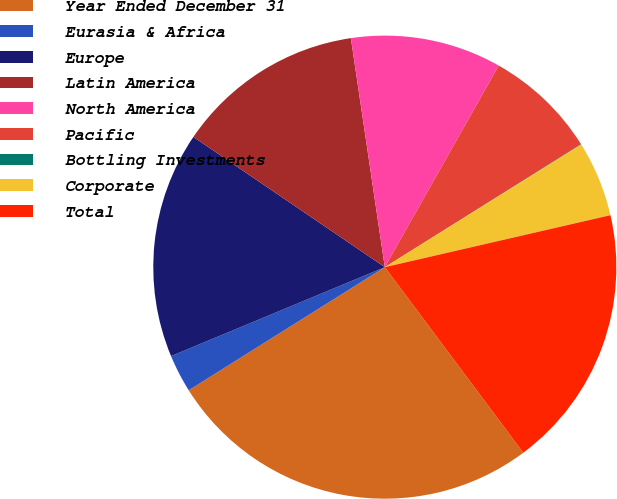Convert chart to OTSL. <chart><loc_0><loc_0><loc_500><loc_500><pie_chart><fcel>Year Ended December 31<fcel>Eurasia & Africa<fcel>Europe<fcel>Latin America<fcel>North America<fcel>Pacific<fcel>Bottling Investments<fcel>Corporate<fcel>Total<nl><fcel>26.28%<fcel>2.65%<fcel>15.78%<fcel>13.15%<fcel>10.53%<fcel>7.9%<fcel>0.03%<fcel>5.28%<fcel>18.4%<nl></chart> 